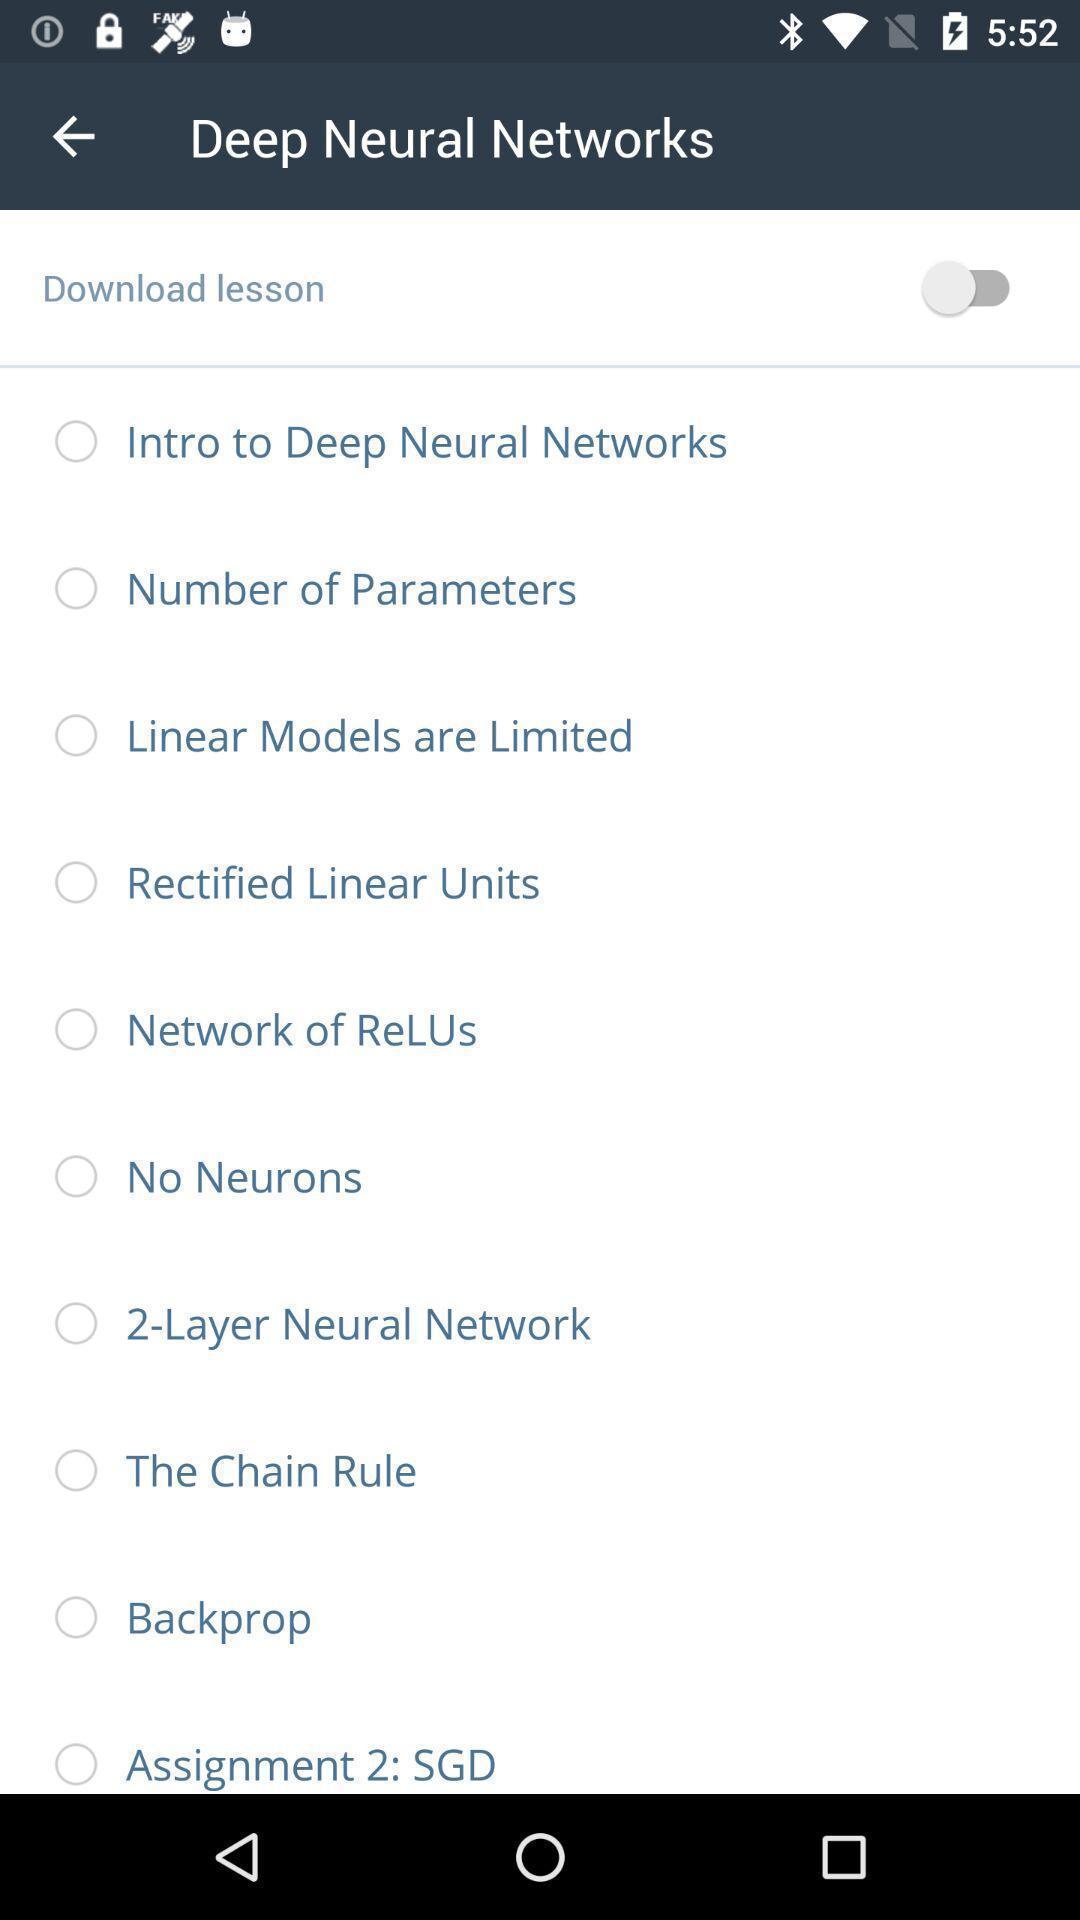What details can you identify in this image? Screen shows neural networks list. 